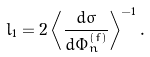Convert formula to latex. <formula><loc_0><loc_0><loc_500><loc_500>l _ { 1 } = 2 \left < \frac { d \sigma } { d \Phi _ { n } ^ { ( f ) } } \right > ^ { - 1 } .</formula> 